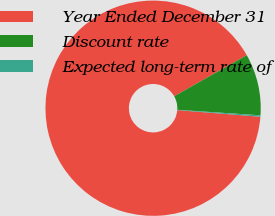Convert chart. <chart><loc_0><loc_0><loc_500><loc_500><pie_chart><fcel>Year Ended December 31<fcel>Discount rate<fcel>Expected long-term rate of<nl><fcel>90.54%<fcel>9.25%<fcel>0.21%<nl></chart> 